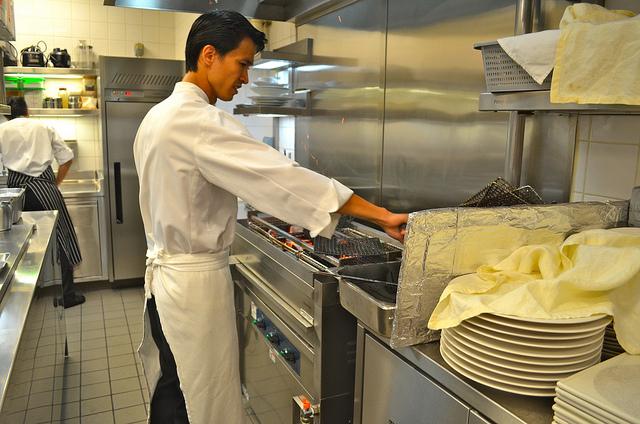Is this a hotel?
Give a very brief answer. No. What is stacked by the man?
Answer briefly. Plates. What is the man cooking?
Keep it brief. Food. 